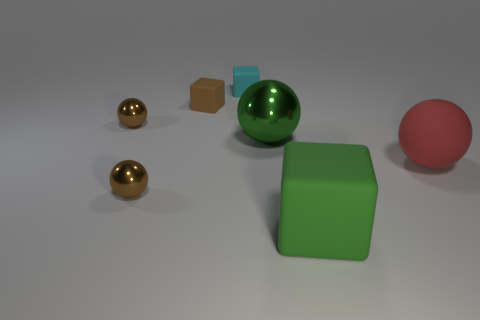Do the brown metal sphere that is in front of the green metallic thing and the ball that is to the right of the green shiny thing have the same size?
Your answer should be compact. No. There is a tiny sphere in front of the large object left of the rubber cube in front of the red object; what is its color?
Provide a short and direct response. Brown. Are there any big brown rubber things of the same shape as the green rubber thing?
Offer a terse response. No. Are there more large balls that are behind the red thing than brown spheres?
Your response must be concise. No. How many rubber objects are big gray blocks or tiny objects?
Keep it short and to the point. 2. What size is the rubber object that is behind the green matte block and in front of the brown rubber block?
Make the answer very short. Large. Is there a brown shiny ball that is left of the brown ball behind the large metallic sphere?
Keep it short and to the point. No. There is a large metallic ball; what number of blocks are behind it?
Your answer should be very brief. 2. What is the color of the other big object that is the same shape as the cyan rubber thing?
Give a very brief answer. Green. Do the tiny ball that is in front of the big red rubber ball and the large sphere on the left side of the matte ball have the same material?
Your response must be concise. Yes. 